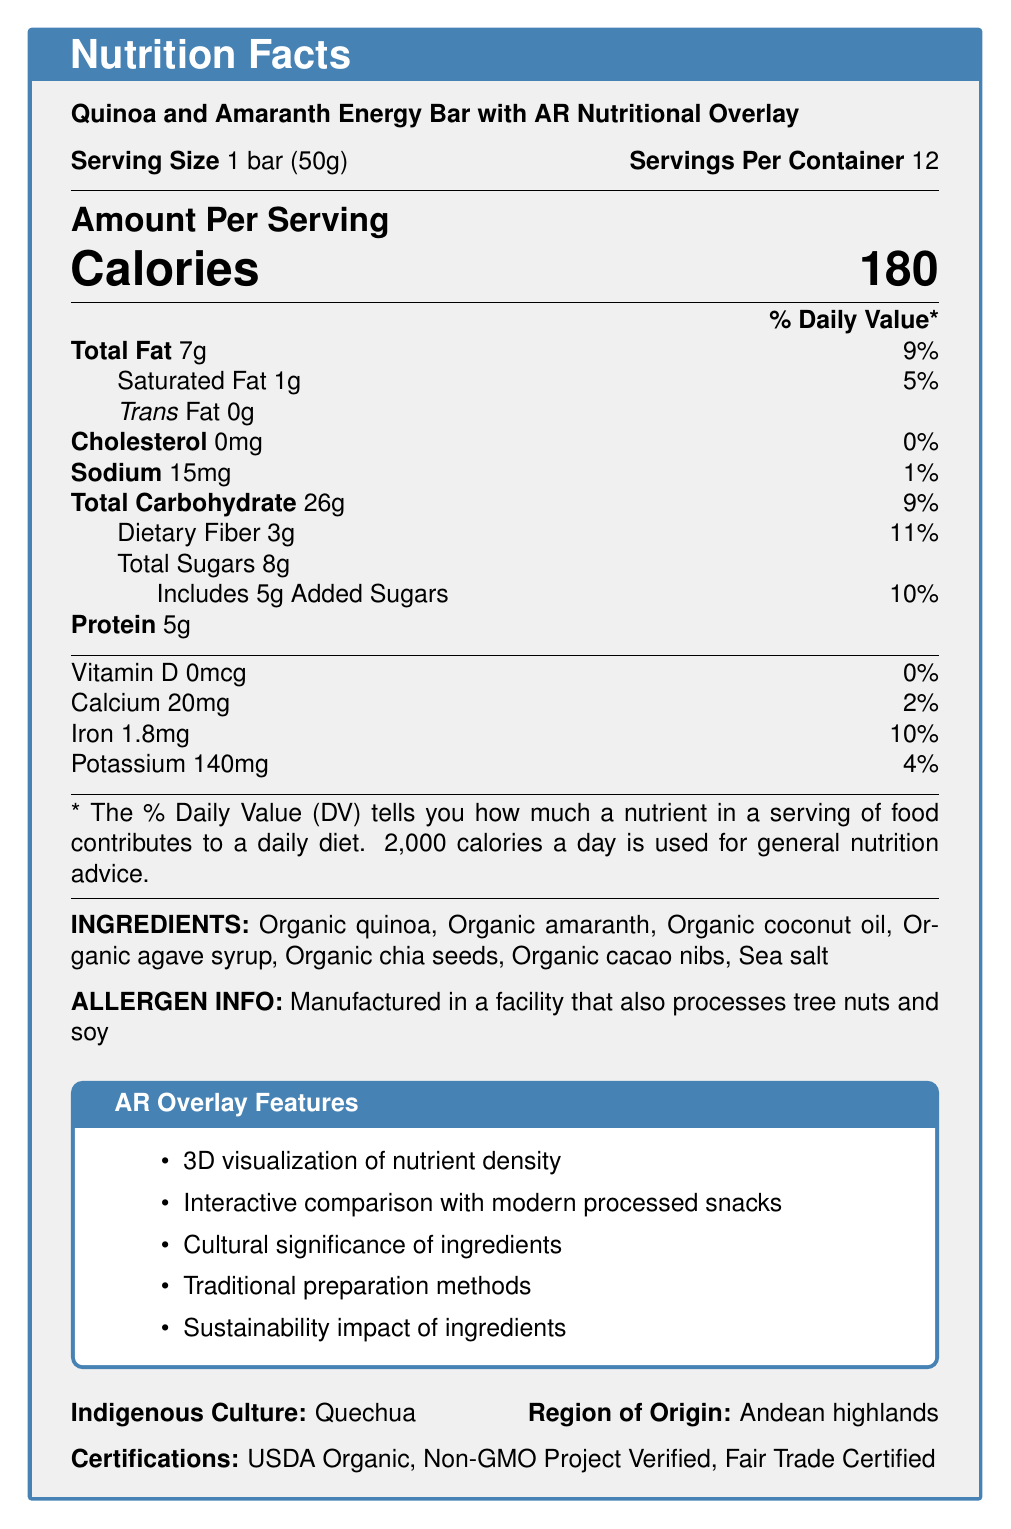what is the serving size? The document states that the serving size is 1 bar which weighs 50 grams.
Answer: 1 bar (50g) what is the calorie content per serving? The document shows that each serving contains 180 calories.
Answer: 180 calories how much dietary fiber is in each serving? The document indicates that there are 3 grams of dietary fiber per serving.
Answer: 3g what is the daily value percentage for saturated fat? The document lists that the daily value percentage for saturated fat is 5%.
Answer: 5% what allergens are mentioned in the document? It states that the product is manufactured in a facility that also processes tree nuts and soy.
Answer: Tree nuts and soy what is the indigenous culture associated with this product? The document mentions that the indigenous culture is Quechua.
Answer: Quechua which ingredient is not organic? A. Organic coconut oil B. Organic agave syrup C. Sea salt The document lists all ingredients as organic except for sea salt.
Answer: C. Sea salt how much calcium does one serving provide? A. 10mg B. 20mg C. 30mg D. 40mg The document specifies that one serving provides 20mg of calcium.
Answer: B. 20mg are there any added sugars in the energy bar? The document states that there are 5 grams of added sugars.
Answer: Yes is the product certified USDA Organic? The document lists USDA Organic among its certifications.
Answer: Yes what types of AR overlay features does this product provide? The document mentions these specific AR overlay features in a tcolorbox.
Answer: 3D visualization of nutrient density, Interactive comparison with modern processed snacks, Cultural significance of ingredients, Traditional preparation methods, Sustainability impact of ingredients what are the traditional uses of this food? The document lists these as traditional uses of the food.
Answer: Ceremonial offerings, Harvest celebrations, Energy source for long treks what is the shelf life of this energy bar? The document states that the shelf life of the energy bar is 12 months.
Answer: 12 months what are the nutritional benefits mentioned? The document mentions these specific nutritional benefits.
Answer: High in complete protein, Rich in essential amino acids, Good source of dietary fiber, Contains antioxidants from cacao nibs which of the following is NOT an AR educational content feature? A. Historical cultivation practices B. Nutritional adaptations to high-altitude environments C. Modern cooking techniques D. Comparison with ancestral diet patterns The document does not list modern cooking techniques as an AR educational content feature.
Answer: C. Modern cooking techniques how is the product preserved? The document states that the product is preserved through vacuum-sealed packaging with an oxygen absorber.
Answer: Vacuum-sealed packaging with oxygen absorber what certifications does the product hold? The document lists these certifications explicitly.
Answer: USDA Organic, Non-GMO Project Verified, Fair Trade Certified which region is the product from? The document mentions that the product's region of origin is the Andean highlands.
Answer: Andean highlands how many servings are there per container? The document states that there are 12 servings per container.
Answer: 12 describe the main idea of the document. The document outlines detailed nutritional facts, the product's ingredients, and its relation to the Quechua culture. Additionally, it lists certifications and AR features that could enhance user interaction and education about indigenous cultures and nutritional benefits.
Answer: The document provides nutritional information, ingredients, certifications, and augmented reality features for the Quinoa and Amaranth Energy Bar. It highlights its health benefits, cultural significance, and methods of preservation. what is the price of a container of bars? The document does not provide any details about the price of the container or the bars.
Answer: Not enough information 